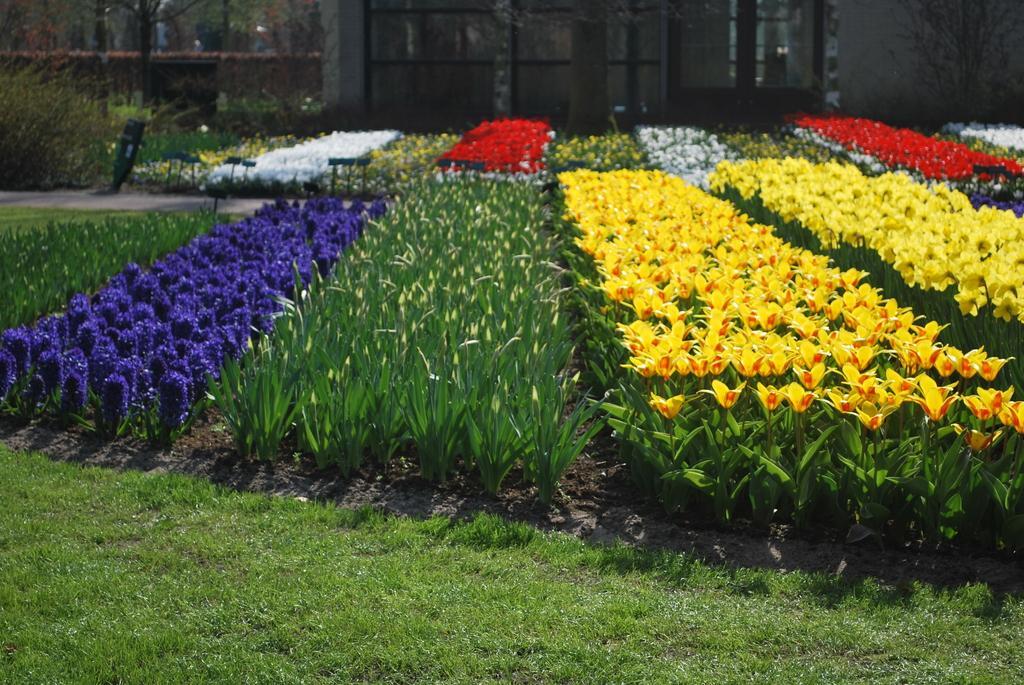Please provide a concise description of this image. In this image there are plants, flowers, trees, wall, glass windows, door, grass and objects.   